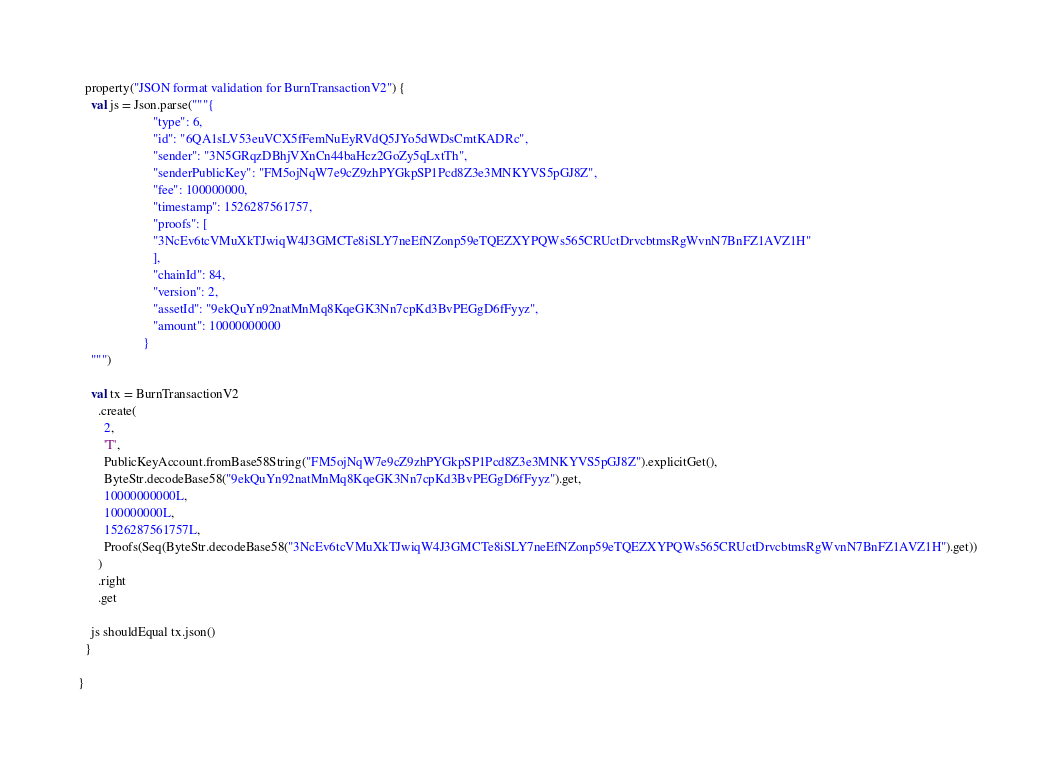Convert code to text. <code><loc_0><loc_0><loc_500><loc_500><_Scala_>  property("JSON format validation for BurnTransactionV2") {
    val js = Json.parse("""{
                       "type": 6,
                       "id": "6QA1sLV53euVCX5fFemNuEyRVdQ5JYo5dWDsCmtKADRc",
                       "sender": "3N5GRqzDBhjVXnCn44baHcz2GoZy5qLxtTh",
                       "senderPublicKey": "FM5ojNqW7e9cZ9zhPYGkpSP1Pcd8Z3e3MNKYVS5pGJ8Z",
                       "fee": 100000000,
                       "timestamp": 1526287561757,
                       "proofs": [
                       "3NcEv6tcVMuXkTJwiqW4J3GMCTe8iSLY7neEfNZonp59eTQEZXYPQWs565CRUctDrvcbtmsRgWvnN7BnFZ1AVZ1H"
                       ],
                       "chainId": 84,
                       "version": 2,
                       "assetId": "9ekQuYn92natMnMq8KqeGK3Nn7cpKd3BvPEGgD6fFyyz",
                       "amount": 10000000000
                    }
    """)

    val tx = BurnTransactionV2
      .create(
        2,
        'T',
        PublicKeyAccount.fromBase58String("FM5ojNqW7e9cZ9zhPYGkpSP1Pcd8Z3e3MNKYVS5pGJ8Z").explicitGet(),
        ByteStr.decodeBase58("9ekQuYn92natMnMq8KqeGK3Nn7cpKd3BvPEGgD6fFyyz").get,
        10000000000L,
        100000000L,
        1526287561757L,
        Proofs(Seq(ByteStr.decodeBase58("3NcEv6tcVMuXkTJwiqW4J3GMCTe8iSLY7neEfNZonp59eTQEZXYPQWs565CRUctDrvcbtmsRgWvnN7BnFZ1AVZ1H").get))
      )
      .right
      .get

    js shouldEqual tx.json()
  }

}
</code> 